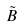Convert formula to latex. <formula><loc_0><loc_0><loc_500><loc_500>\tilde { B }</formula> 